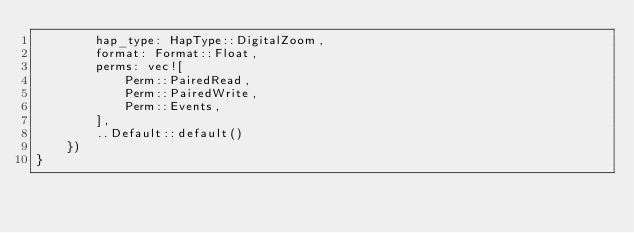<code> <loc_0><loc_0><loc_500><loc_500><_Rust_>        hap_type: HapType::DigitalZoom,
        format: Format::Float,
        perms: vec![
			Perm::PairedRead,
			Perm::PairedWrite,
			Perm::Events,
        ],
        ..Default::default()
    })
}
</code> 